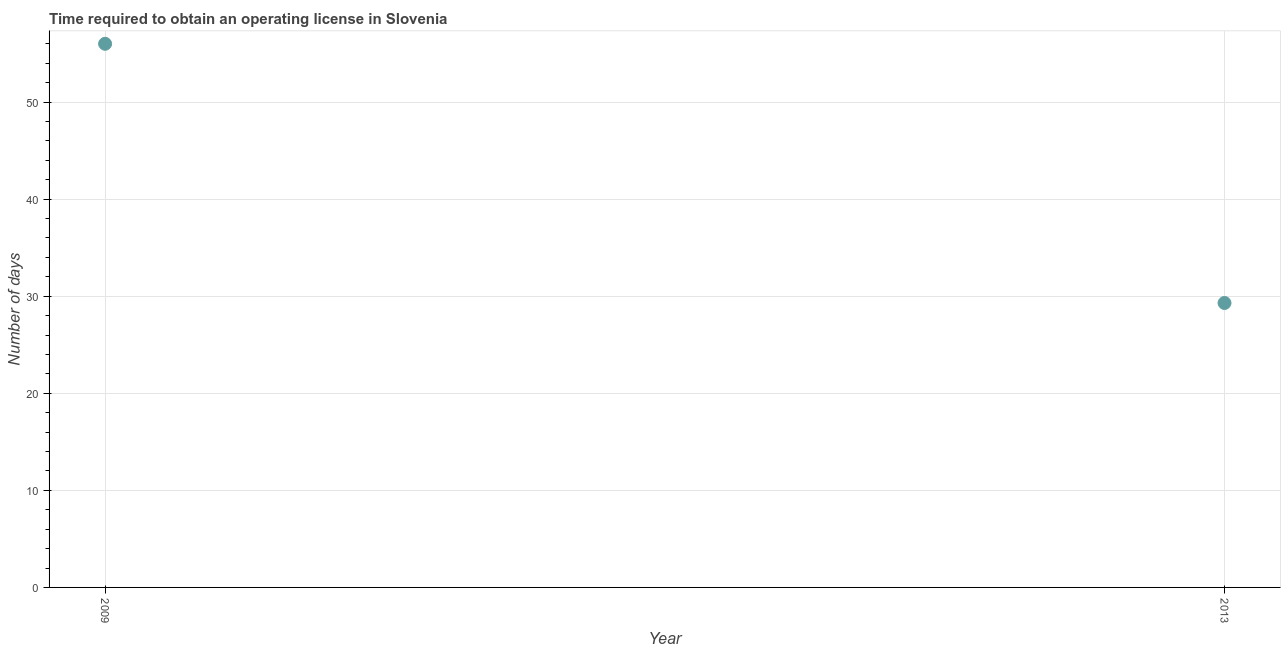What is the number of days to obtain operating license in 2009?
Give a very brief answer. 56. Across all years, what is the maximum number of days to obtain operating license?
Offer a very short reply. 56. Across all years, what is the minimum number of days to obtain operating license?
Your response must be concise. 29.3. What is the sum of the number of days to obtain operating license?
Give a very brief answer. 85.3. What is the difference between the number of days to obtain operating license in 2009 and 2013?
Provide a short and direct response. 26.7. What is the average number of days to obtain operating license per year?
Your response must be concise. 42.65. What is the median number of days to obtain operating license?
Offer a very short reply. 42.65. In how many years, is the number of days to obtain operating license greater than 52 days?
Your response must be concise. 1. Do a majority of the years between 2009 and 2013 (inclusive) have number of days to obtain operating license greater than 48 days?
Your response must be concise. No. What is the ratio of the number of days to obtain operating license in 2009 to that in 2013?
Offer a very short reply. 1.91. In how many years, is the number of days to obtain operating license greater than the average number of days to obtain operating license taken over all years?
Offer a very short reply. 1. Does the number of days to obtain operating license monotonically increase over the years?
Offer a terse response. No. How many dotlines are there?
Provide a short and direct response. 1. Are the values on the major ticks of Y-axis written in scientific E-notation?
Keep it short and to the point. No. What is the title of the graph?
Keep it short and to the point. Time required to obtain an operating license in Slovenia. What is the label or title of the X-axis?
Ensure brevity in your answer.  Year. What is the label or title of the Y-axis?
Keep it short and to the point. Number of days. What is the Number of days in 2009?
Provide a succinct answer. 56. What is the Number of days in 2013?
Ensure brevity in your answer.  29.3. What is the difference between the Number of days in 2009 and 2013?
Offer a very short reply. 26.7. What is the ratio of the Number of days in 2009 to that in 2013?
Offer a very short reply. 1.91. 